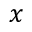Convert formula to latex. <formula><loc_0><loc_0><loc_500><loc_500>x</formula> 